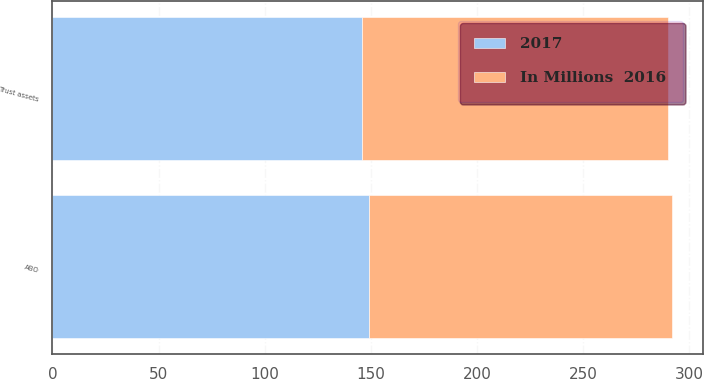<chart> <loc_0><loc_0><loc_500><loc_500><stacked_bar_chart><ecel><fcel>Trust assets<fcel>ABO<nl><fcel>2017<fcel>146<fcel>149<nl><fcel>In Millions  2016<fcel>144<fcel>143<nl></chart> 